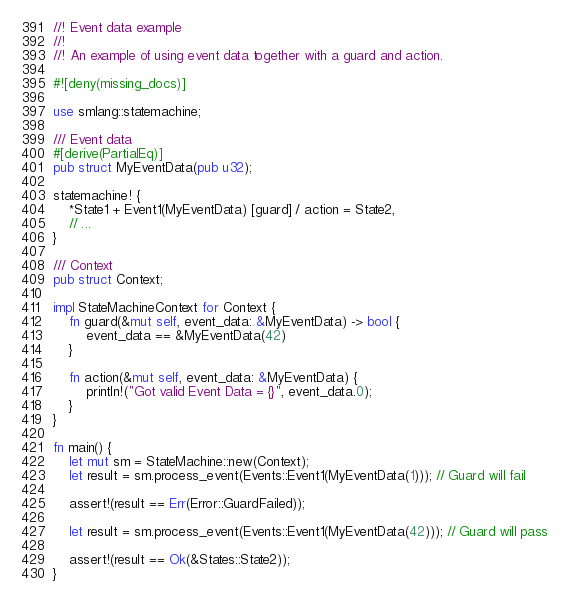<code> <loc_0><loc_0><loc_500><loc_500><_Rust_>//! Event data example
//!
//! An example of using event data together with a guard and action.

#![deny(missing_docs)]

use smlang::statemachine;

/// Event data
#[derive(PartialEq)]
pub struct MyEventData(pub u32);

statemachine! {
    *State1 + Event1(MyEventData) [guard] / action = State2,
    // ...
}

/// Context
pub struct Context;

impl StateMachineContext for Context {
    fn guard(&mut self, event_data: &MyEventData) -> bool {
        event_data == &MyEventData(42)
    }

    fn action(&mut self, event_data: &MyEventData) {
        println!("Got valid Event Data = {}", event_data.0);
    }
}

fn main() {
    let mut sm = StateMachine::new(Context);
    let result = sm.process_event(Events::Event1(MyEventData(1))); // Guard will fail

    assert!(result == Err(Error::GuardFailed));

    let result = sm.process_event(Events::Event1(MyEventData(42))); // Guard will pass

    assert!(result == Ok(&States::State2));
}
</code> 